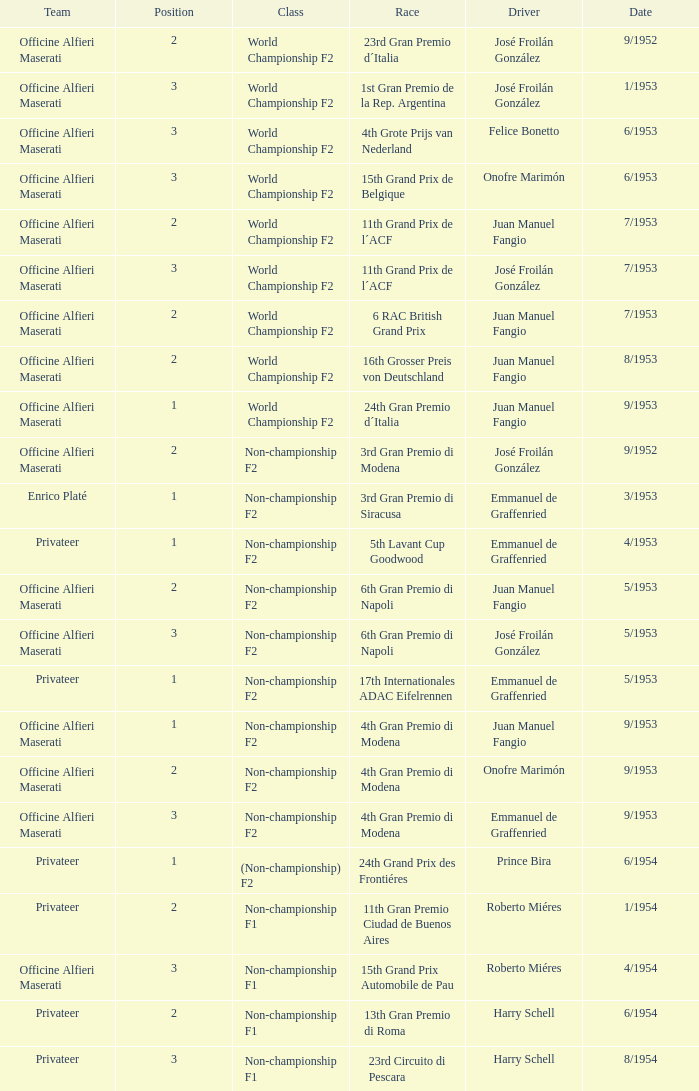What class has the date of 8/1954? Non-championship F1. 